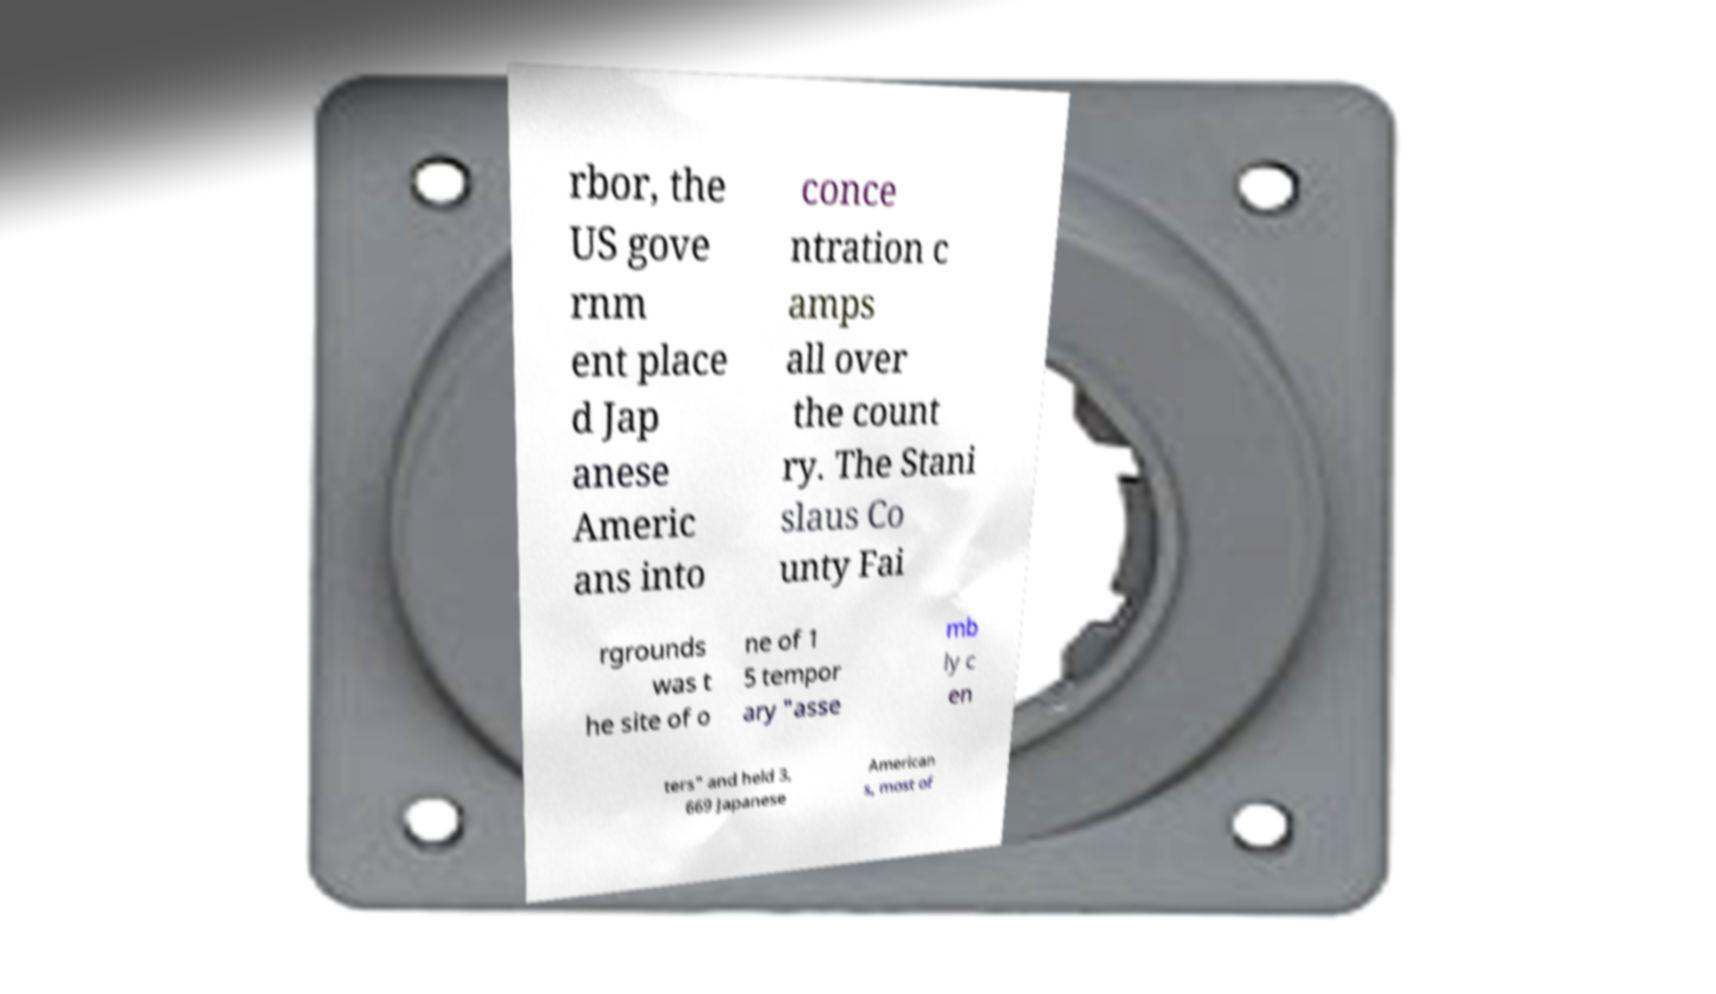Could you assist in decoding the text presented in this image and type it out clearly? rbor, the US gove rnm ent place d Jap anese Americ ans into conce ntration c amps all over the count ry. The Stani slaus Co unty Fai rgrounds was t he site of o ne of 1 5 tempor ary "asse mb ly c en ters" and held 3, 669 Japanese American s, most of 